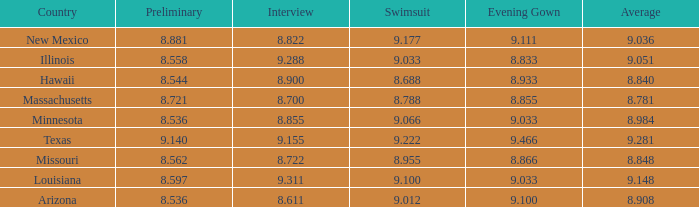What was the swimsuit score for the country with the average score of 8.848? 8.955. 